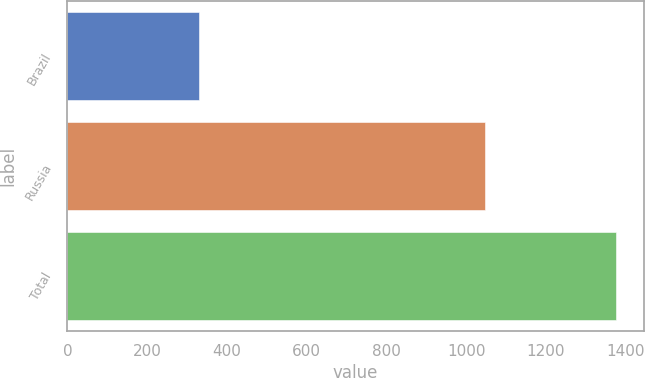Convert chart. <chart><loc_0><loc_0><loc_500><loc_500><bar_chart><fcel>Brazil<fcel>Russia<fcel>Total<nl><fcel>329<fcel>1047<fcel>1376<nl></chart> 